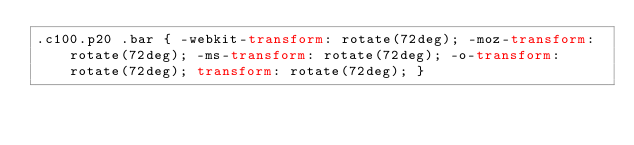Convert code to text. <code><loc_0><loc_0><loc_500><loc_500><_CSS_>.c100.p20 .bar { -webkit-transform: rotate(72deg); -moz-transform: rotate(72deg); -ms-transform: rotate(72deg); -o-transform: rotate(72deg); transform: rotate(72deg); }</code> 